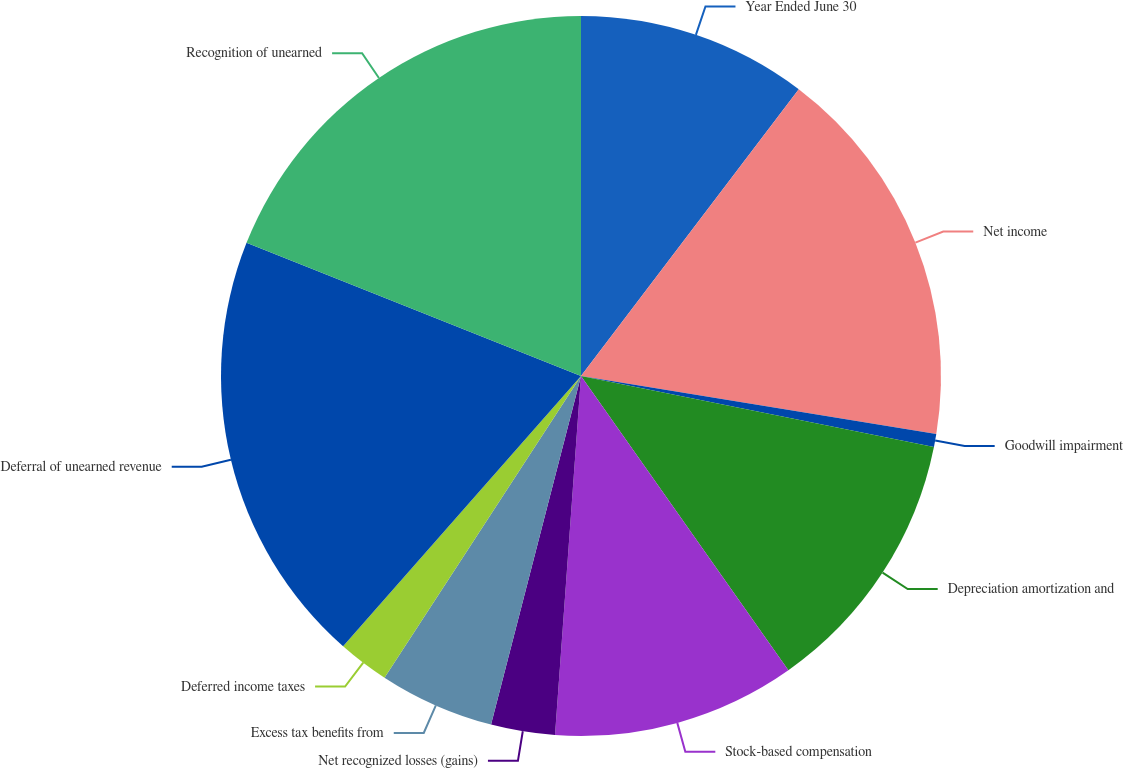<chart> <loc_0><loc_0><loc_500><loc_500><pie_chart><fcel>Year Ended June 30<fcel>Net income<fcel>Goodwill impairment<fcel>Depreciation amortization and<fcel>Stock-based compensation<fcel>Net recognized losses (gains)<fcel>Excess tax benefits from<fcel>Deferred income taxes<fcel>Deferral of unearned revenue<fcel>Recognition of unearned<nl><fcel>10.34%<fcel>17.24%<fcel>0.58%<fcel>12.07%<fcel>10.92%<fcel>2.87%<fcel>5.17%<fcel>2.3%<fcel>19.54%<fcel>18.97%<nl></chart> 